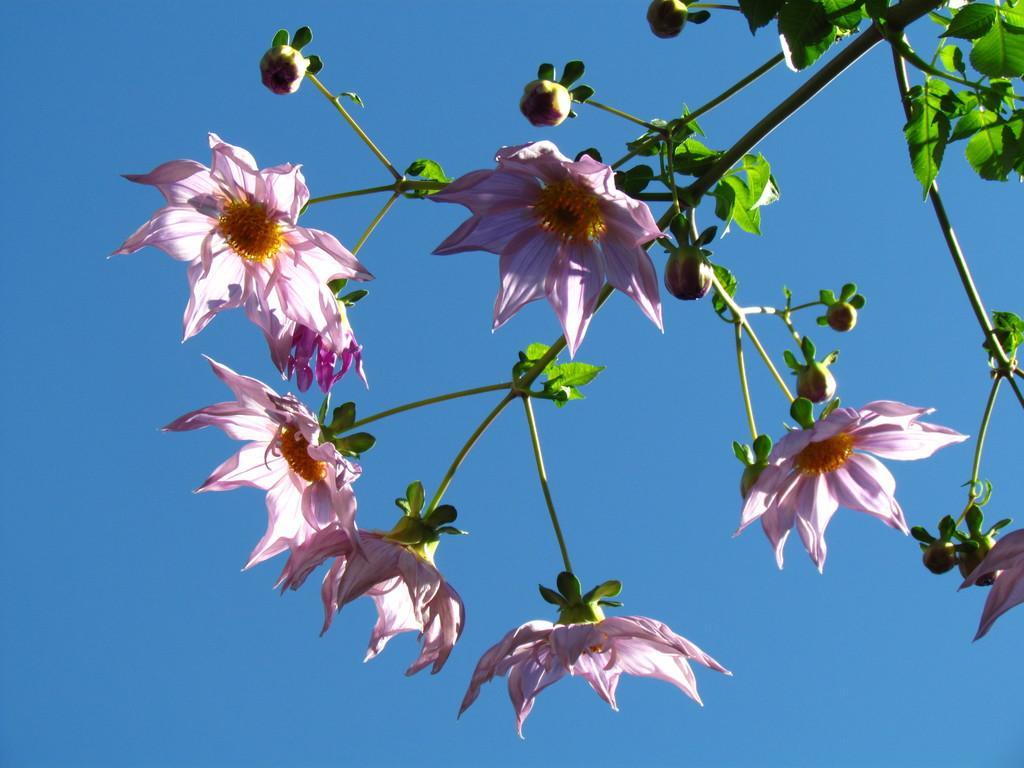Please provide a concise description of this image. There is a tree having pink color flowers and green color leaves. In the background, there is blue sky. 